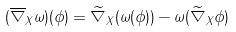<formula> <loc_0><loc_0><loc_500><loc_500>( \overline { \nabla } _ { X } \omega ) ( \phi ) = \widetilde { \nabla } _ { X } ( \omega ( \phi ) ) - \omega ( \widetilde { \nabla } _ { X } \phi )</formula> 